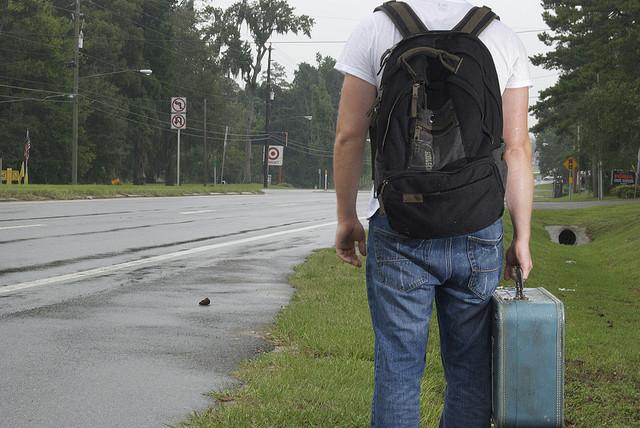Why is the road wet?
Short answer required. Rain. What color is the backpack?
Short answer required. Black. What is the man carrying?
Quick response, please. Suitcase. 